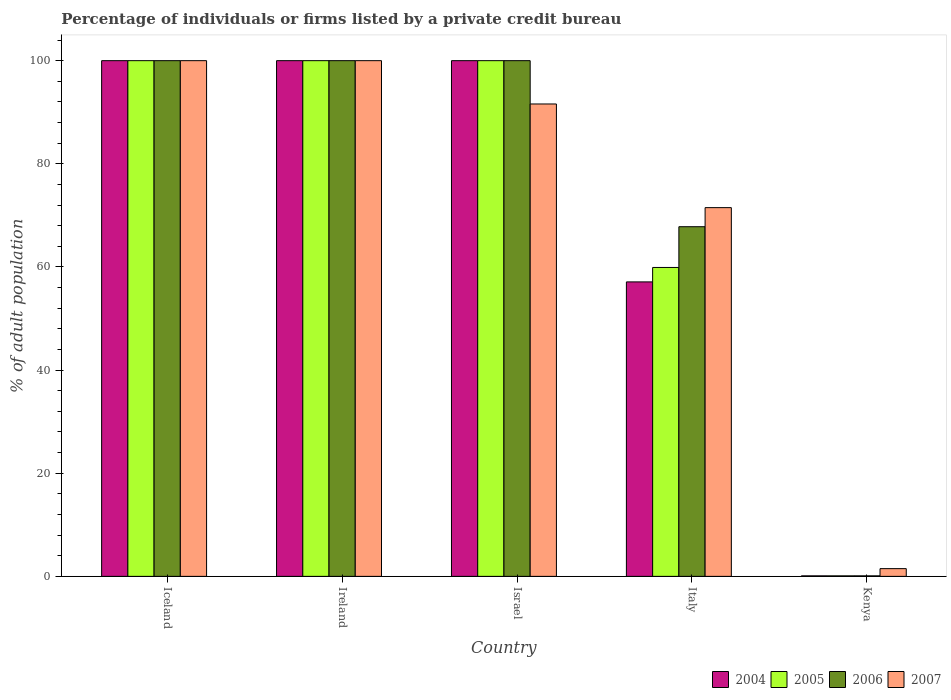How many different coloured bars are there?
Keep it short and to the point. 4. Are the number of bars per tick equal to the number of legend labels?
Provide a short and direct response. Yes. In how many cases, is the number of bars for a given country not equal to the number of legend labels?
Keep it short and to the point. 0. What is the percentage of population listed by a private credit bureau in 2006 in Ireland?
Offer a terse response. 100. In which country was the percentage of population listed by a private credit bureau in 2006 minimum?
Offer a very short reply. Kenya. What is the total percentage of population listed by a private credit bureau in 2004 in the graph?
Ensure brevity in your answer.  357.2. What is the difference between the percentage of population listed by a private credit bureau in 2007 in Iceland and that in Italy?
Give a very brief answer. 28.5. What is the difference between the percentage of population listed by a private credit bureau in 2006 in Ireland and the percentage of population listed by a private credit bureau in 2004 in Kenya?
Keep it short and to the point. 99.9. What is the ratio of the percentage of population listed by a private credit bureau in 2007 in Iceland to that in Kenya?
Your answer should be compact. 66.67. Is the percentage of population listed by a private credit bureau in 2004 in Iceland less than that in Italy?
Provide a short and direct response. No. Is the difference between the percentage of population listed by a private credit bureau in 2005 in Israel and Italy greater than the difference between the percentage of population listed by a private credit bureau in 2006 in Israel and Italy?
Ensure brevity in your answer.  Yes. What is the difference between the highest and the second highest percentage of population listed by a private credit bureau in 2007?
Give a very brief answer. -8.4. What is the difference between the highest and the lowest percentage of population listed by a private credit bureau in 2005?
Provide a short and direct response. 99.9. In how many countries, is the percentage of population listed by a private credit bureau in 2004 greater than the average percentage of population listed by a private credit bureau in 2004 taken over all countries?
Provide a short and direct response. 3. What does the 2nd bar from the left in Ireland represents?
Your answer should be compact. 2005. How many countries are there in the graph?
Provide a succinct answer. 5. Does the graph contain grids?
Keep it short and to the point. No. How many legend labels are there?
Your response must be concise. 4. How are the legend labels stacked?
Give a very brief answer. Horizontal. What is the title of the graph?
Your response must be concise. Percentage of individuals or firms listed by a private credit bureau. Does "1971" appear as one of the legend labels in the graph?
Offer a terse response. No. What is the label or title of the X-axis?
Provide a short and direct response. Country. What is the label or title of the Y-axis?
Ensure brevity in your answer.  % of adult population. What is the % of adult population in 2005 in Ireland?
Your answer should be compact. 100. What is the % of adult population of 2006 in Ireland?
Offer a very short reply. 100. What is the % of adult population in 2007 in Ireland?
Your response must be concise. 100. What is the % of adult population of 2006 in Israel?
Ensure brevity in your answer.  100. What is the % of adult population in 2007 in Israel?
Offer a terse response. 91.6. What is the % of adult population of 2004 in Italy?
Your response must be concise. 57.1. What is the % of adult population of 2005 in Italy?
Ensure brevity in your answer.  59.9. What is the % of adult population of 2006 in Italy?
Provide a succinct answer. 67.8. What is the % of adult population of 2007 in Italy?
Ensure brevity in your answer.  71.5. What is the % of adult population of 2004 in Kenya?
Make the answer very short. 0.1. What is the % of adult population of 2005 in Kenya?
Keep it short and to the point. 0.1. What is the % of adult population in 2006 in Kenya?
Offer a very short reply. 0.1. What is the % of adult population in 2007 in Kenya?
Give a very brief answer. 1.5. Across all countries, what is the maximum % of adult population of 2004?
Provide a short and direct response. 100. Across all countries, what is the maximum % of adult population of 2006?
Your response must be concise. 100. Across all countries, what is the minimum % of adult population of 2006?
Make the answer very short. 0.1. Across all countries, what is the minimum % of adult population of 2007?
Your response must be concise. 1.5. What is the total % of adult population of 2004 in the graph?
Your response must be concise. 357.2. What is the total % of adult population in 2005 in the graph?
Ensure brevity in your answer.  360. What is the total % of adult population of 2006 in the graph?
Ensure brevity in your answer.  367.9. What is the total % of adult population in 2007 in the graph?
Give a very brief answer. 364.6. What is the difference between the % of adult population in 2004 in Iceland and that in Ireland?
Your answer should be compact. 0. What is the difference between the % of adult population of 2005 in Iceland and that in Ireland?
Your answer should be compact. 0. What is the difference between the % of adult population in 2007 in Iceland and that in Ireland?
Make the answer very short. 0. What is the difference between the % of adult population of 2005 in Iceland and that in Israel?
Your answer should be compact. 0. What is the difference between the % of adult population of 2007 in Iceland and that in Israel?
Provide a short and direct response. 8.4. What is the difference between the % of adult population of 2004 in Iceland and that in Italy?
Your response must be concise. 42.9. What is the difference between the % of adult population in 2005 in Iceland and that in Italy?
Your response must be concise. 40.1. What is the difference between the % of adult population in 2006 in Iceland and that in Italy?
Offer a very short reply. 32.2. What is the difference between the % of adult population in 2004 in Iceland and that in Kenya?
Your answer should be very brief. 99.9. What is the difference between the % of adult population in 2005 in Iceland and that in Kenya?
Offer a very short reply. 99.9. What is the difference between the % of adult population of 2006 in Iceland and that in Kenya?
Provide a succinct answer. 99.9. What is the difference between the % of adult population in 2007 in Iceland and that in Kenya?
Your answer should be very brief. 98.5. What is the difference between the % of adult population of 2004 in Ireland and that in Israel?
Give a very brief answer. 0. What is the difference between the % of adult population in 2005 in Ireland and that in Israel?
Ensure brevity in your answer.  0. What is the difference between the % of adult population of 2006 in Ireland and that in Israel?
Provide a short and direct response. 0. What is the difference between the % of adult population of 2004 in Ireland and that in Italy?
Give a very brief answer. 42.9. What is the difference between the % of adult population of 2005 in Ireland and that in Italy?
Give a very brief answer. 40.1. What is the difference between the % of adult population in 2006 in Ireland and that in Italy?
Keep it short and to the point. 32.2. What is the difference between the % of adult population of 2007 in Ireland and that in Italy?
Offer a very short reply. 28.5. What is the difference between the % of adult population of 2004 in Ireland and that in Kenya?
Provide a short and direct response. 99.9. What is the difference between the % of adult population of 2005 in Ireland and that in Kenya?
Your response must be concise. 99.9. What is the difference between the % of adult population of 2006 in Ireland and that in Kenya?
Provide a short and direct response. 99.9. What is the difference between the % of adult population in 2007 in Ireland and that in Kenya?
Your answer should be very brief. 98.5. What is the difference between the % of adult population of 2004 in Israel and that in Italy?
Keep it short and to the point. 42.9. What is the difference between the % of adult population in 2005 in Israel and that in Italy?
Make the answer very short. 40.1. What is the difference between the % of adult population in 2006 in Israel and that in Italy?
Keep it short and to the point. 32.2. What is the difference between the % of adult population in 2007 in Israel and that in Italy?
Make the answer very short. 20.1. What is the difference between the % of adult population of 2004 in Israel and that in Kenya?
Offer a terse response. 99.9. What is the difference between the % of adult population of 2005 in Israel and that in Kenya?
Make the answer very short. 99.9. What is the difference between the % of adult population in 2006 in Israel and that in Kenya?
Your response must be concise. 99.9. What is the difference between the % of adult population in 2007 in Israel and that in Kenya?
Your response must be concise. 90.1. What is the difference between the % of adult population of 2005 in Italy and that in Kenya?
Your answer should be very brief. 59.8. What is the difference between the % of adult population of 2006 in Italy and that in Kenya?
Offer a very short reply. 67.7. What is the difference between the % of adult population of 2007 in Italy and that in Kenya?
Your response must be concise. 70. What is the difference between the % of adult population of 2004 in Iceland and the % of adult population of 2005 in Ireland?
Keep it short and to the point. 0. What is the difference between the % of adult population in 2005 in Iceland and the % of adult population in 2006 in Ireland?
Offer a terse response. 0. What is the difference between the % of adult population in 2005 in Iceland and the % of adult population in 2007 in Ireland?
Offer a terse response. 0. What is the difference between the % of adult population of 2006 in Iceland and the % of adult population of 2007 in Ireland?
Provide a short and direct response. 0. What is the difference between the % of adult population in 2004 in Iceland and the % of adult population in 2005 in Israel?
Your response must be concise. 0. What is the difference between the % of adult population of 2004 in Iceland and the % of adult population of 2006 in Israel?
Offer a very short reply. 0. What is the difference between the % of adult population of 2005 in Iceland and the % of adult population of 2006 in Israel?
Offer a very short reply. 0. What is the difference between the % of adult population in 2005 in Iceland and the % of adult population in 2007 in Israel?
Offer a very short reply. 8.4. What is the difference between the % of adult population in 2004 in Iceland and the % of adult population in 2005 in Italy?
Offer a very short reply. 40.1. What is the difference between the % of adult population of 2004 in Iceland and the % of adult population of 2006 in Italy?
Ensure brevity in your answer.  32.2. What is the difference between the % of adult population in 2005 in Iceland and the % of adult population in 2006 in Italy?
Keep it short and to the point. 32.2. What is the difference between the % of adult population in 2006 in Iceland and the % of adult population in 2007 in Italy?
Provide a short and direct response. 28.5. What is the difference between the % of adult population in 2004 in Iceland and the % of adult population in 2005 in Kenya?
Ensure brevity in your answer.  99.9. What is the difference between the % of adult population in 2004 in Iceland and the % of adult population in 2006 in Kenya?
Offer a terse response. 99.9. What is the difference between the % of adult population in 2004 in Iceland and the % of adult population in 2007 in Kenya?
Offer a very short reply. 98.5. What is the difference between the % of adult population in 2005 in Iceland and the % of adult population in 2006 in Kenya?
Keep it short and to the point. 99.9. What is the difference between the % of adult population of 2005 in Iceland and the % of adult population of 2007 in Kenya?
Offer a terse response. 98.5. What is the difference between the % of adult population in 2006 in Iceland and the % of adult population in 2007 in Kenya?
Offer a terse response. 98.5. What is the difference between the % of adult population in 2004 in Ireland and the % of adult population in 2005 in Israel?
Your response must be concise. 0. What is the difference between the % of adult population of 2004 in Ireland and the % of adult population of 2007 in Israel?
Offer a very short reply. 8.4. What is the difference between the % of adult population in 2005 in Ireland and the % of adult population in 2006 in Israel?
Make the answer very short. 0. What is the difference between the % of adult population of 2005 in Ireland and the % of adult population of 2007 in Israel?
Provide a succinct answer. 8.4. What is the difference between the % of adult population of 2004 in Ireland and the % of adult population of 2005 in Italy?
Provide a short and direct response. 40.1. What is the difference between the % of adult population in 2004 in Ireland and the % of adult population in 2006 in Italy?
Your response must be concise. 32.2. What is the difference between the % of adult population of 2004 in Ireland and the % of adult population of 2007 in Italy?
Offer a very short reply. 28.5. What is the difference between the % of adult population of 2005 in Ireland and the % of adult population of 2006 in Italy?
Make the answer very short. 32.2. What is the difference between the % of adult population of 2005 in Ireland and the % of adult population of 2007 in Italy?
Make the answer very short. 28.5. What is the difference between the % of adult population in 2006 in Ireland and the % of adult population in 2007 in Italy?
Offer a terse response. 28.5. What is the difference between the % of adult population in 2004 in Ireland and the % of adult population in 2005 in Kenya?
Ensure brevity in your answer.  99.9. What is the difference between the % of adult population of 2004 in Ireland and the % of adult population of 2006 in Kenya?
Provide a succinct answer. 99.9. What is the difference between the % of adult population in 2004 in Ireland and the % of adult population in 2007 in Kenya?
Offer a terse response. 98.5. What is the difference between the % of adult population of 2005 in Ireland and the % of adult population of 2006 in Kenya?
Your answer should be very brief. 99.9. What is the difference between the % of adult population of 2005 in Ireland and the % of adult population of 2007 in Kenya?
Provide a short and direct response. 98.5. What is the difference between the % of adult population of 2006 in Ireland and the % of adult population of 2007 in Kenya?
Make the answer very short. 98.5. What is the difference between the % of adult population in 2004 in Israel and the % of adult population in 2005 in Italy?
Provide a succinct answer. 40.1. What is the difference between the % of adult population in 2004 in Israel and the % of adult population in 2006 in Italy?
Your answer should be compact. 32.2. What is the difference between the % of adult population of 2004 in Israel and the % of adult population of 2007 in Italy?
Offer a terse response. 28.5. What is the difference between the % of adult population of 2005 in Israel and the % of adult population of 2006 in Italy?
Your answer should be very brief. 32.2. What is the difference between the % of adult population of 2005 in Israel and the % of adult population of 2007 in Italy?
Your response must be concise. 28.5. What is the difference between the % of adult population of 2006 in Israel and the % of adult population of 2007 in Italy?
Provide a succinct answer. 28.5. What is the difference between the % of adult population of 2004 in Israel and the % of adult population of 2005 in Kenya?
Keep it short and to the point. 99.9. What is the difference between the % of adult population in 2004 in Israel and the % of adult population in 2006 in Kenya?
Keep it short and to the point. 99.9. What is the difference between the % of adult population of 2004 in Israel and the % of adult population of 2007 in Kenya?
Ensure brevity in your answer.  98.5. What is the difference between the % of adult population in 2005 in Israel and the % of adult population in 2006 in Kenya?
Your answer should be compact. 99.9. What is the difference between the % of adult population in 2005 in Israel and the % of adult population in 2007 in Kenya?
Provide a short and direct response. 98.5. What is the difference between the % of adult population of 2006 in Israel and the % of adult population of 2007 in Kenya?
Offer a terse response. 98.5. What is the difference between the % of adult population of 2004 in Italy and the % of adult population of 2005 in Kenya?
Your answer should be compact. 57. What is the difference between the % of adult population in 2004 in Italy and the % of adult population in 2007 in Kenya?
Provide a succinct answer. 55.6. What is the difference between the % of adult population in 2005 in Italy and the % of adult population in 2006 in Kenya?
Keep it short and to the point. 59.8. What is the difference between the % of adult population in 2005 in Italy and the % of adult population in 2007 in Kenya?
Your answer should be very brief. 58.4. What is the difference between the % of adult population in 2006 in Italy and the % of adult population in 2007 in Kenya?
Offer a terse response. 66.3. What is the average % of adult population in 2004 per country?
Offer a very short reply. 71.44. What is the average % of adult population in 2005 per country?
Offer a very short reply. 72. What is the average % of adult population of 2006 per country?
Give a very brief answer. 73.58. What is the average % of adult population in 2007 per country?
Provide a succinct answer. 72.92. What is the difference between the % of adult population of 2004 and % of adult population of 2006 in Iceland?
Give a very brief answer. 0. What is the difference between the % of adult population of 2004 and % of adult population of 2007 in Iceland?
Your response must be concise. 0. What is the difference between the % of adult population in 2004 and % of adult population in 2005 in Ireland?
Ensure brevity in your answer.  0. What is the difference between the % of adult population in 2004 and % of adult population in 2006 in Ireland?
Make the answer very short. 0. What is the difference between the % of adult population of 2005 and % of adult population of 2006 in Ireland?
Your answer should be very brief. 0. What is the difference between the % of adult population in 2004 and % of adult population in 2005 in Israel?
Provide a succinct answer. 0. What is the difference between the % of adult population in 2004 and % of adult population in 2007 in Israel?
Offer a very short reply. 8.4. What is the difference between the % of adult population in 2005 and % of adult population in 2006 in Israel?
Provide a short and direct response. 0. What is the difference between the % of adult population of 2004 and % of adult population of 2005 in Italy?
Provide a short and direct response. -2.8. What is the difference between the % of adult population of 2004 and % of adult population of 2007 in Italy?
Give a very brief answer. -14.4. What is the difference between the % of adult population in 2004 and % of adult population in 2005 in Kenya?
Your response must be concise. 0. What is the difference between the % of adult population of 2004 and % of adult population of 2006 in Kenya?
Give a very brief answer. 0. What is the difference between the % of adult population of 2004 and % of adult population of 2007 in Kenya?
Your answer should be very brief. -1.4. What is the difference between the % of adult population in 2006 and % of adult population in 2007 in Kenya?
Offer a very short reply. -1.4. What is the ratio of the % of adult population in 2006 in Iceland to that in Ireland?
Give a very brief answer. 1. What is the ratio of the % of adult population of 2007 in Iceland to that in Ireland?
Keep it short and to the point. 1. What is the ratio of the % of adult population in 2005 in Iceland to that in Israel?
Provide a succinct answer. 1. What is the ratio of the % of adult population in 2006 in Iceland to that in Israel?
Your response must be concise. 1. What is the ratio of the % of adult population in 2007 in Iceland to that in Israel?
Keep it short and to the point. 1.09. What is the ratio of the % of adult population in 2004 in Iceland to that in Italy?
Give a very brief answer. 1.75. What is the ratio of the % of adult population in 2005 in Iceland to that in Italy?
Your response must be concise. 1.67. What is the ratio of the % of adult population in 2006 in Iceland to that in Italy?
Make the answer very short. 1.47. What is the ratio of the % of adult population of 2007 in Iceland to that in Italy?
Your answer should be very brief. 1.4. What is the ratio of the % of adult population in 2004 in Iceland to that in Kenya?
Your answer should be compact. 1000. What is the ratio of the % of adult population of 2006 in Iceland to that in Kenya?
Offer a terse response. 1000. What is the ratio of the % of adult population of 2007 in Iceland to that in Kenya?
Provide a short and direct response. 66.67. What is the ratio of the % of adult population of 2005 in Ireland to that in Israel?
Your answer should be very brief. 1. What is the ratio of the % of adult population of 2007 in Ireland to that in Israel?
Your answer should be very brief. 1.09. What is the ratio of the % of adult population in 2004 in Ireland to that in Italy?
Your answer should be very brief. 1.75. What is the ratio of the % of adult population of 2005 in Ireland to that in Italy?
Give a very brief answer. 1.67. What is the ratio of the % of adult population in 2006 in Ireland to that in Italy?
Your response must be concise. 1.47. What is the ratio of the % of adult population of 2007 in Ireland to that in Italy?
Your answer should be very brief. 1.4. What is the ratio of the % of adult population in 2007 in Ireland to that in Kenya?
Offer a terse response. 66.67. What is the ratio of the % of adult population of 2004 in Israel to that in Italy?
Your answer should be compact. 1.75. What is the ratio of the % of adult population in 2005 in Israel to that in Italy?
Your response must be concise. 1.67. What is the ratio of the % of adult population in 2006 in Israel to that in Italy?
Offer a very short reply. 1.47. What is the ratio of the % of adult population in 2007 in Israel to that in Italy?
Offer a terse response. 1.28. What is the ratio of the % of adult population of 2004 in Israel to that in Kenya?
Make the answer very short. 1000. What is the ratio of the % of adult population of 2006 in Israel to that in Kenya?
Your answer should be very brief. 1000. What is the ratio of the % of adult population in 2007 in Israel to that in Kenya?
Your response must be concise. 61.07. What is the ratio of the % of adult population in 2004 in Italy to that in Kenya?
Give a very brief answer. 571. What is the ratio of the % of adult population of 2005 in Italy to that in Kenya?
Provide a succinct answer. 599. What is the ratio of the % of adult population of 2006 in Italy to that in Kenya?
Your response must be concise. 678. What is the ratio of the % of adult population of 2007 in Italy to that in Kenya?
Give a very brief answer. 47.67. What is the difference between the highest and the lowest % of adult population in 2004?
Offer a very short reply. 99.9. What is the difference between the highest and the lowest % of adult population in 2005?
Keep it short and to the point. 99.9. What is the difference between the highest and the lowest % of adult population in 2006?
Provide a short and direct response. 99.9. What is the difference between the highest and the lowest % of adult population of 2007?
Offer a very short reply. 98.5. 